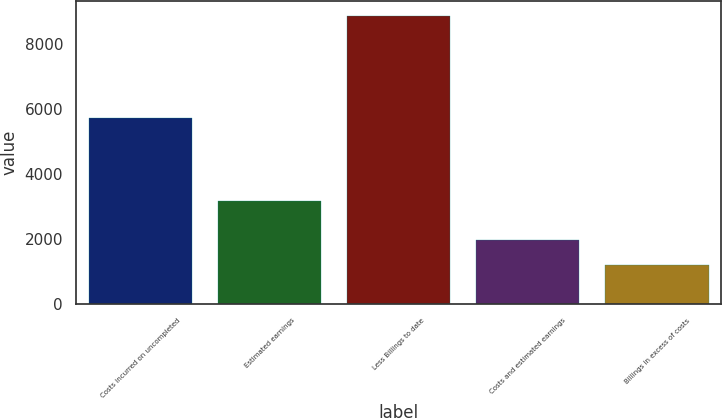<chart> <loc_0><loc_0><loc_500><loc_500><bar_chart><fcel>Costs incurred on uncompleted<fcel>Estimated earnings<fcel>Less Billings to date<fcel>Costs and estimated earnings<fcel>Billings in excess of costs<nl><fcel>5731<fcel>3160<fcel>8855<fcel>1955.6<fcel>1189<nl></chart> 